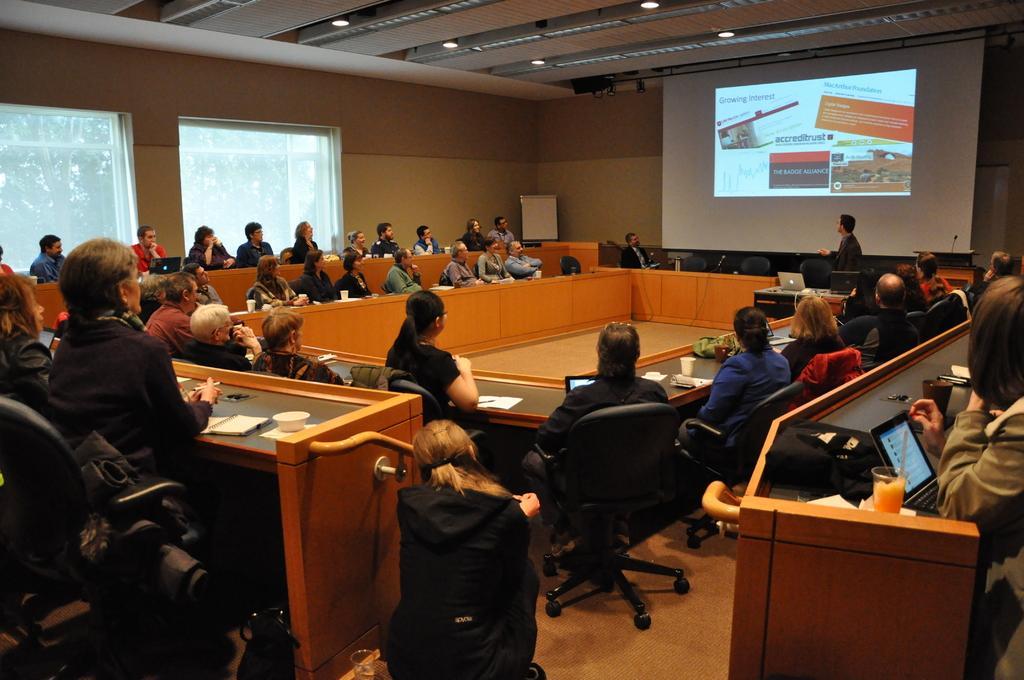Please provide a concise description of this image. In this image, we can see a group of people. Here we can see few people are sitting on the chairs. On the right side of the image, we can see a person is standing near the screen. Background we can see wallboard, few objects and windows. Top of the image, we can see the ceiling and lights. 